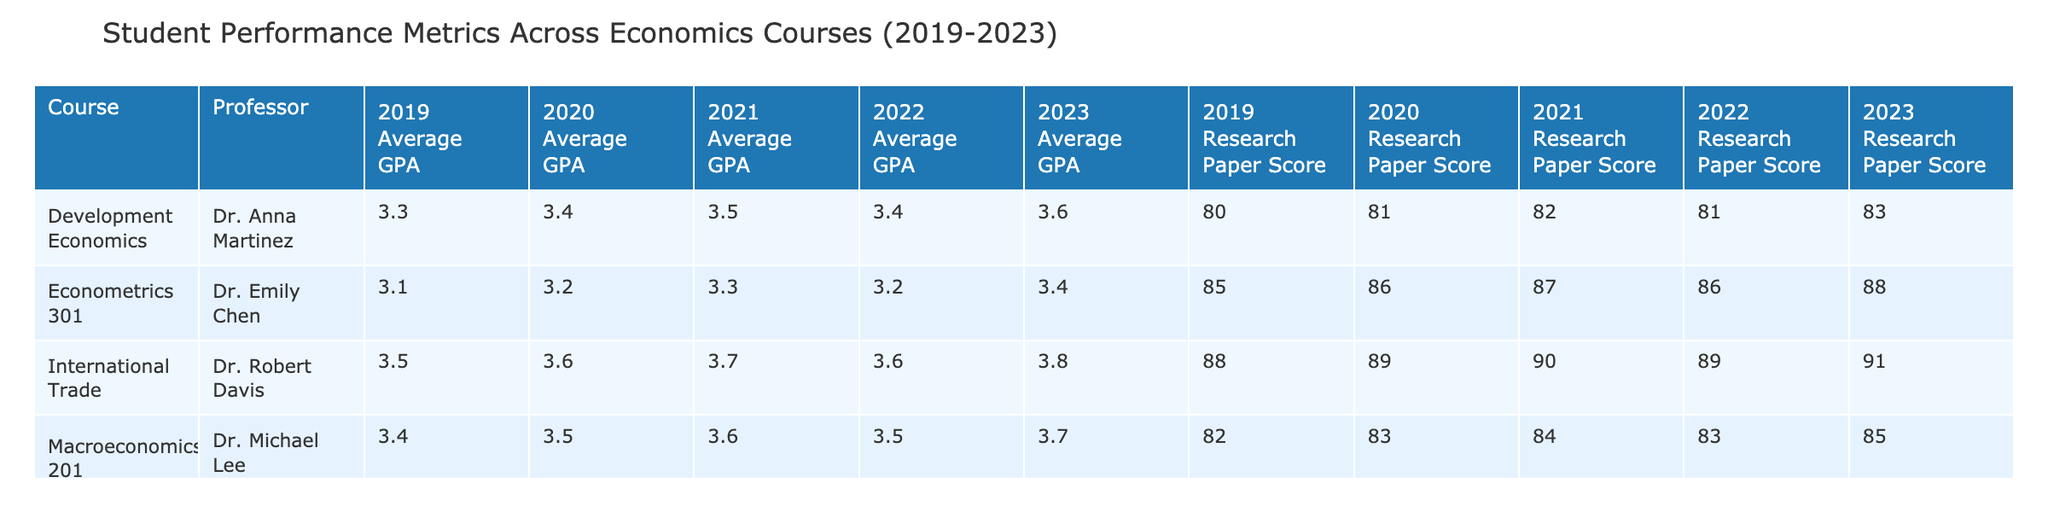What was the average GPA for Microeconomics 101 in 2023? The table shows the values for Average GPA for each year and course. For Microeconomics 101 in 2023, the Average GPA is listed as 3.5.
Answer: 3.5 What is the highest Pass Rate recorded for Econometrics 301 from 2019 to 2023? By examining the Pass Rate values for Econometrics 301 over the years, the Pass Rates are as follows: 88% (2019), 90% (2020), 91% (2021), 90% (2022), and 92% (2023). The highest is 92%.
Answer: 92% Which course had the lowest average GPA over the last 5 years? The Average GPA values for each course across the years need to be summed and averaged. For all years, Econometrics 301 has the lowest average GPA of 3.2 across its years at 3.1, 3.2, 3.3, 3.2, and 3.4.
Answer: 3.2 Did the internship placement rate for International Trade improve from 2019 to 2023? The internship placement rates for International Trade are: 80% (2019), 82% (2020), 85% (2021), 83% (2022), and 87% (2023). By comparing the years, the rate consistently increased each year.
Answer: Yes What was the overall increase in Research Paper Scores for Microeconomics 101 from 2019 to 2023? For Microeconomics 101, the Research Paper Scores over the years are as follows: 78 (2019), 79 (2020), 80 (2021), 79 (2022), and 81 (2023). Calculating the difference from 2019 to 2023 gives 81 - 78 = 3.
Answer: 3 